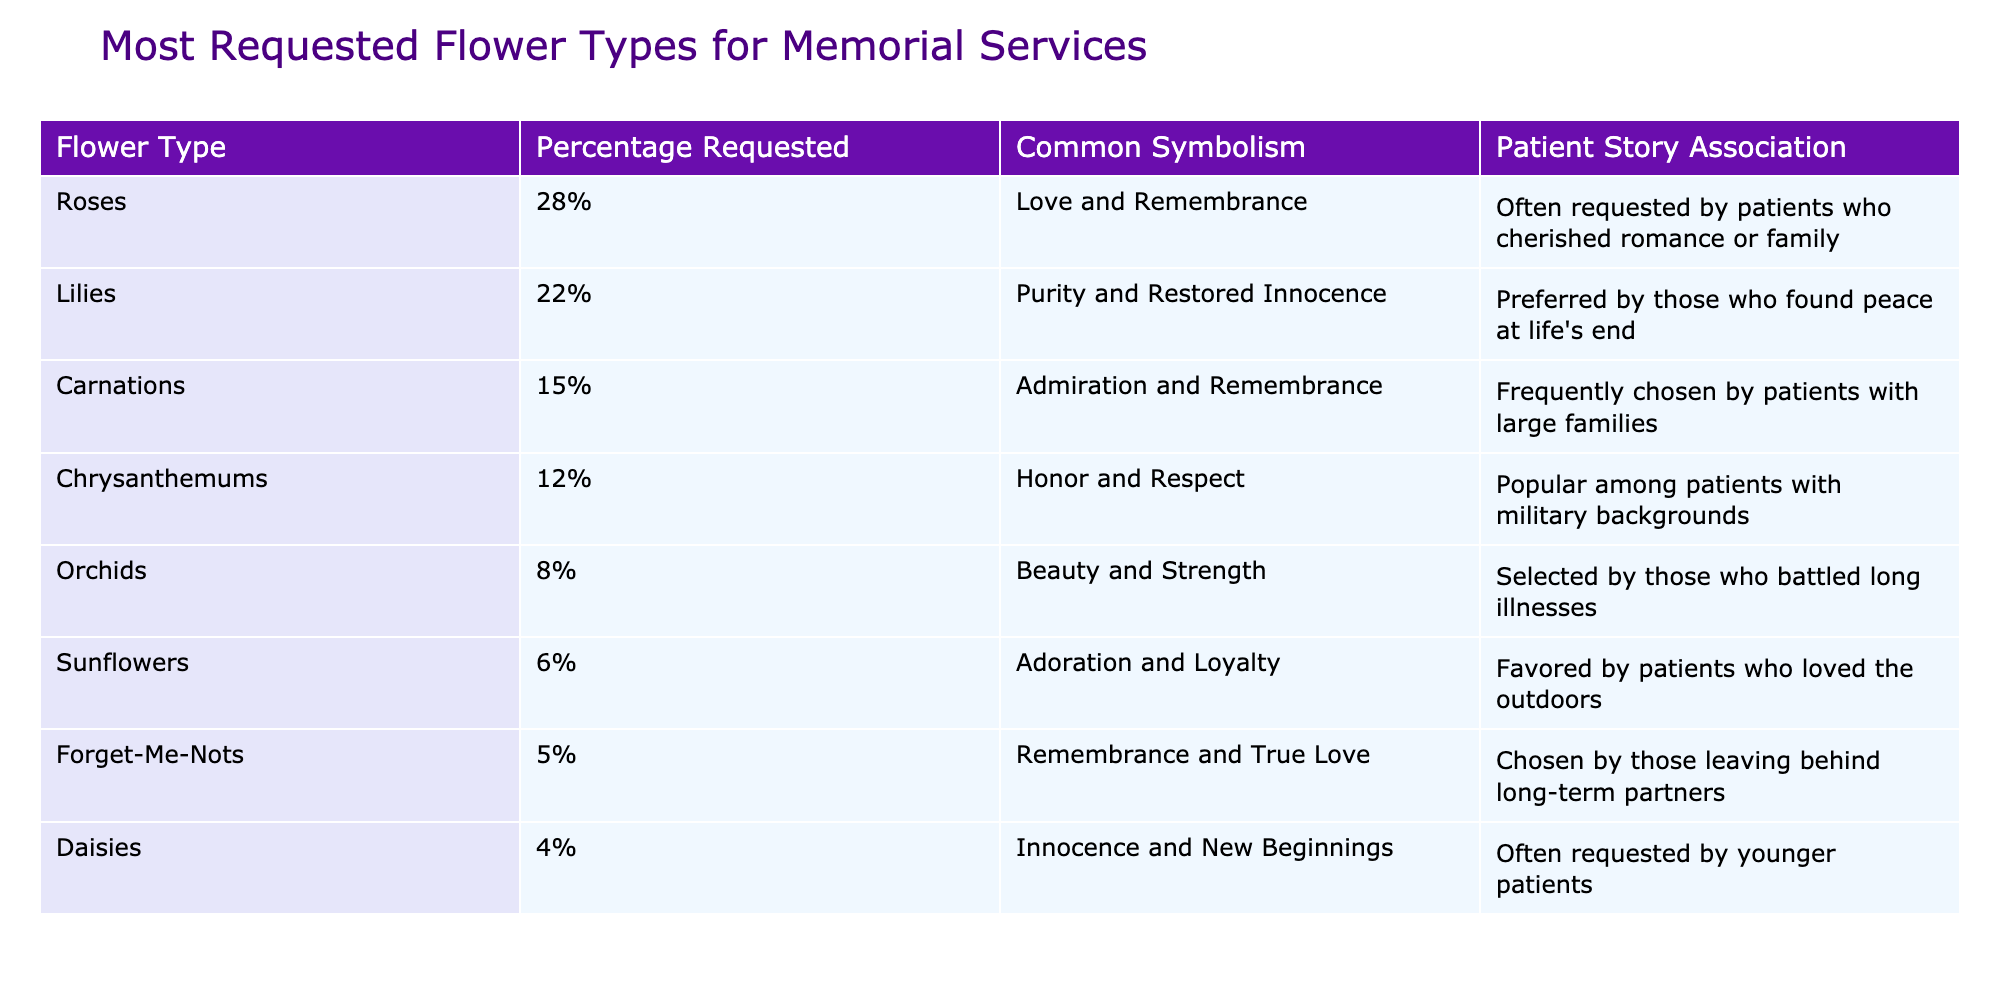What percentage of requests were for roses? According to the table, roses account for 28% of the requests for memorial service flowers.
Answer: 28% Which flower type symbolizes purity and restored innocence? The table shows that lilies symbolize purity and restored innocence.
Answer: Lilies What is the total percentage of requests for orchids and sunflowers combined? Orchids account for 8% and sunflowers for 6%. Adding these percentages gives us 8 + 6 = 14%.
Answer: 14% Is it true that carnations are associated with admiration? Yes, the table explicitly states that carnations symbolize admiration and remembrance.
Answer: Yes Which flower type is least requested for memorial services? The table indicates that daisies have the lowest percentage of requests at 4%.
Answer: Daisies What percentage of patients preferred flowers associated with military backgrounds (chrysanthemums)? The table shows that chrysanthemums are requested by 12% of patients, so this is the percentage representing those with military backgrounds.
Answer: 12% What is the difference in percentage between the requests for roses and chrysanthemums? Roses have a percentage of 28%, while chrysanthemums have 12%. The difference is calculated as 28 - 12 = 16%.
Answer: 16% How many flower types have a request percentage of 10% or lower? Looking at the table, the flower types with 10% or lower are orchids (8%), sunflowers (6%), forget-me-nots (5%), and daisies (4%), totaling four types.
Answer: 4 Which flower type had associations with long-term partners? The table indicates that forget-me-nots are chosen by patients leaving behind long-term partners.
Answer: Forget-Me-Nots 